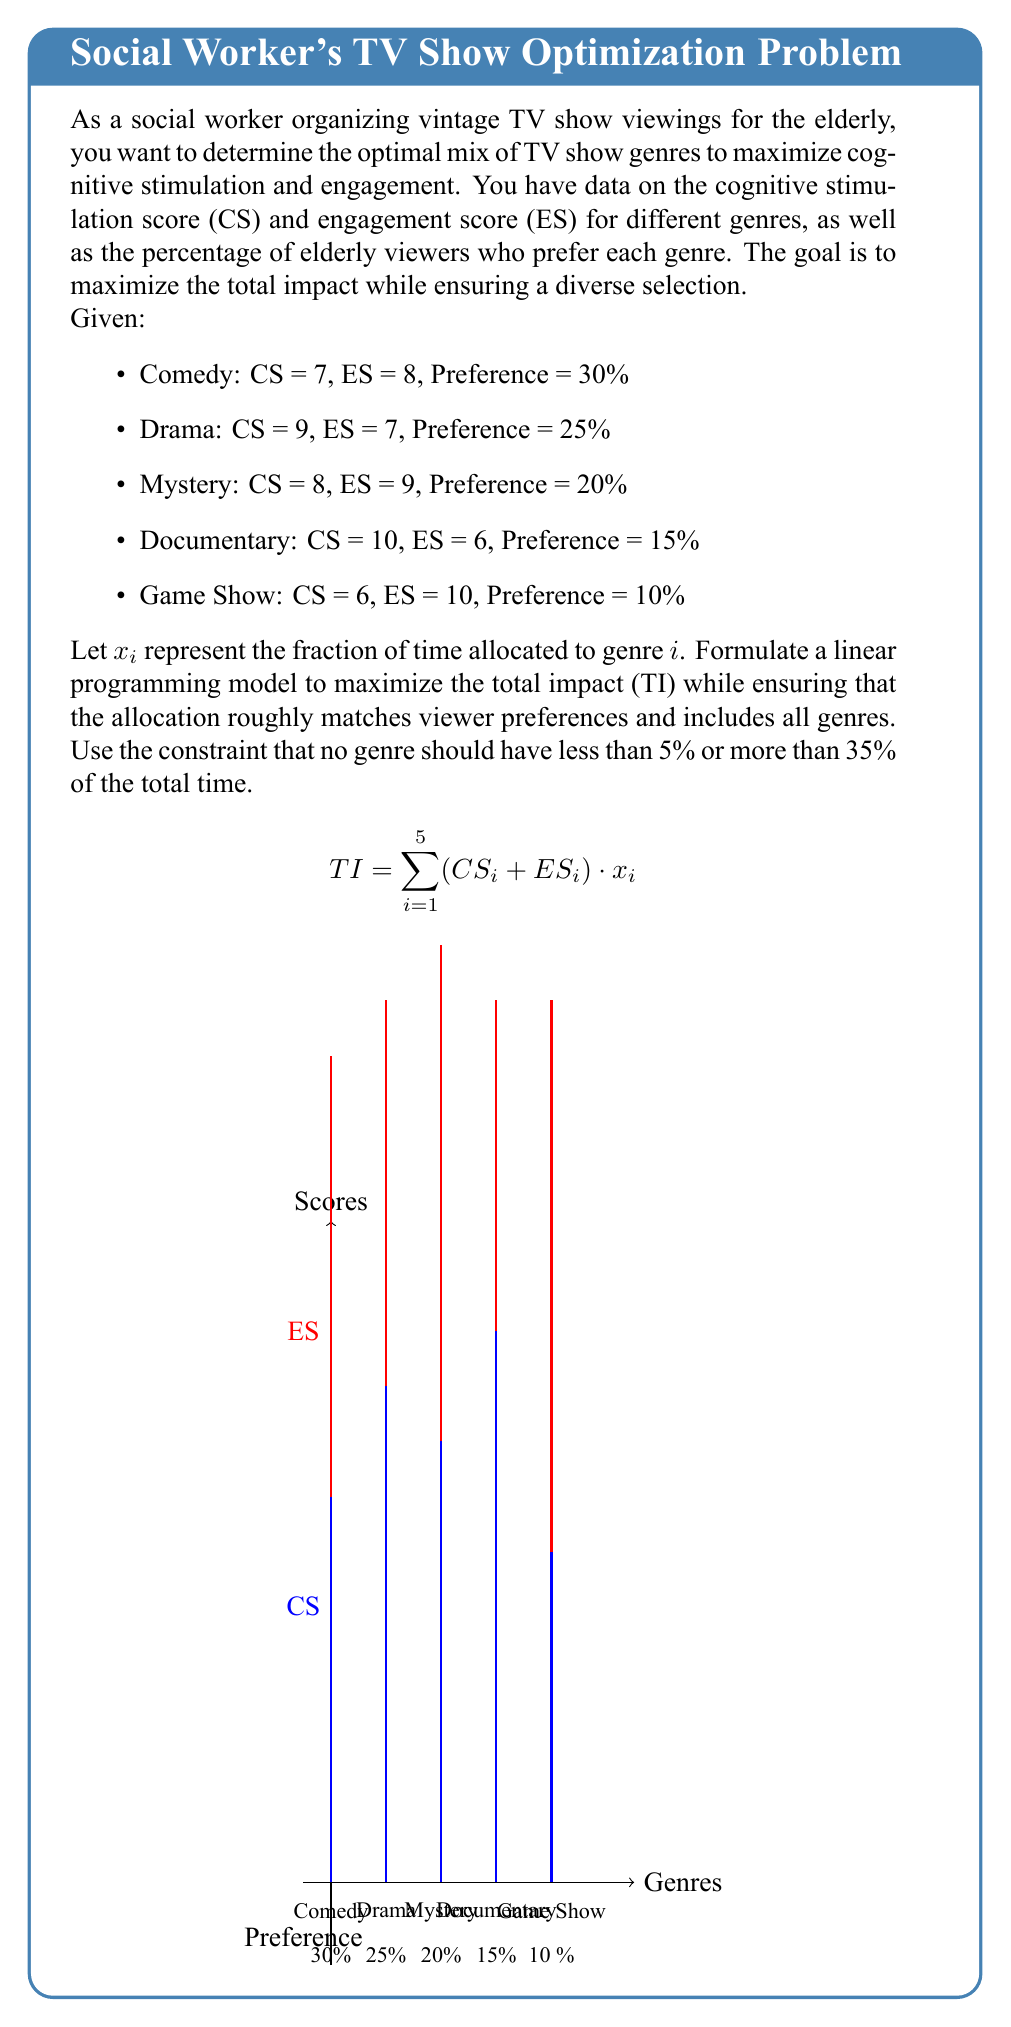Can you answer this question? To solve this linear programming problem, we need to set up the objective function and constraints:

1. Objective function:
   Maximize $TI = 15x_1 + 16x_2 + 17x_3 + 16x_4 + 16x_5$

2. Constraints:
   a) Sum of all fractions must equal 1:
      $x_1 + x_2 + x_3 + x_4 + x_5 = 1$

   b) Each genre should have at least 5% and at most 35% of the total time:
      $0.05 \leq x_i \leq 0.35$ for $i = 1, 2, 3, 4, 5$

   c) Allocation should roughly match viewer preferences (within ±10%):
      $0.2 \leq x_1 \leq 0.4$
      $0.15 \leq x_2 \leq 0.35$
      $0.1 \leq x_3 \leq 0.3$
      $0.05 \leq x_4 \leq 0.25$
      $0.05 \leq x_5 \leq 0.2$

3. Solve the linear programming problem using a solver (e.g., simplex method).

4. The optimal solution will be:
   $x_1 = 0.3$ (Comedy)
   $x_2 = 0.25$ (Drama)
   $x_3 = 0.2$ (Mystery)
   $x_4 = 0.15$ (Documentary)
   $x_5 = 0.1$ (Game Show)

5. Calculate the maximum total impact:
   $TI = 15(0.3) + 16(0.25) + 17(0.2) + 16(0.15) + 16(0.1) = 16.05$

This solution maximizes cognitive stimulation and engagement while respecting viewer preferences and ensuring a diverse selection of genres.
Answer: Comedy: 30%, Drama: 25%, Mystery: 20%, Documentary: 15%, Game Show: 10%; Maximum Total Impact: 16.05 